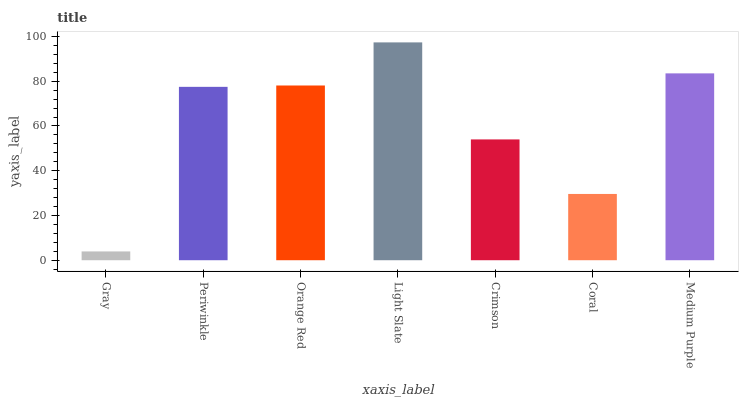Is Periwinkle the minimum?
Answer yes or no. No. Is Periwinkle the maximum?
Answer yes or no. No. Is Periwinkle greater than Gray?
Answer yes or no. Yes. Is Gray less than Periwinkle?
Answer yes or no. Yes. Is Gray greater than Periwinkle?
Answer yes or no. No. Is Periwinkle less than Gray?
Answer yes or no. No. Is Periwinkle the high median?
Answer yes or no. Yes. Is Periwinkle the low median?
Answer yes or no. Yes. Is Light Slate the high median?
Answer yes or no. No. Is Light Slate the low median?
Answer yes or no. No. 